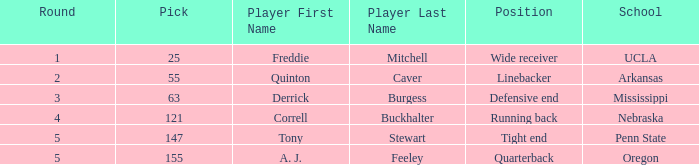What position did a. j. feeley play who was picked in round 5? Quarterback. 